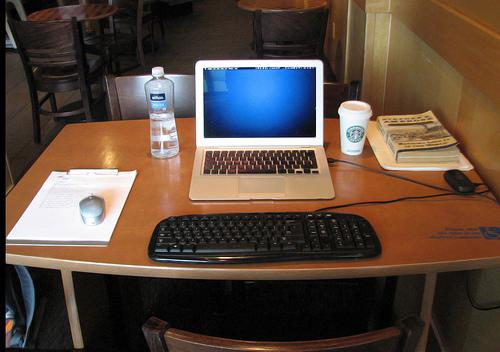Provide an informal description of a few items seen on the table. A cool white laptop, a tall water bottle, a tasty Starbucks coffee, and a fancy black keyboard are chilling on the table. Choose a beverage item from the image and describe it with its location. A clear plastic water bottle is placed on a brown wooden table near a white laptop computer. Describe an interaction among two objects in the image. A silver wireless computer mouse is used with a small white laptop computer, placed on a brown wooden table. Write a sentence about the laptop and computer mouse in the image. A white laptop with a black keyboard is placed next to a silver wireless computer mouse on a wooden table. Provide a brief summary of the most noticeable items in the image. A laptop, a water bottle, a coffee cup, a computer mouse, a keyboard, and a book are placed on a wooden table near a dining room chair. In the image, mention an item and one of its specific characteristics. There's a clear plastic water bottle with a label, placed on the wooden table. Mention one electronic item in the image and its color. A black computer keyboard is placed on a brown wooden table. Describe one object in the image and its placement in relation to another object. A paper Starbucks coffee cup is on the table, next to a small white laptop computer. List five items placed on the table in the image. Laptop, water bottle, coffee cup, computer mouse, and a stack of papers with a book on it. Mention the central objects in the image along with their colors. A white laptop, a transparent water bottle, a paper Starbucks coffee cup, a black keyboard, and a wooden table with a brown chair are present. 